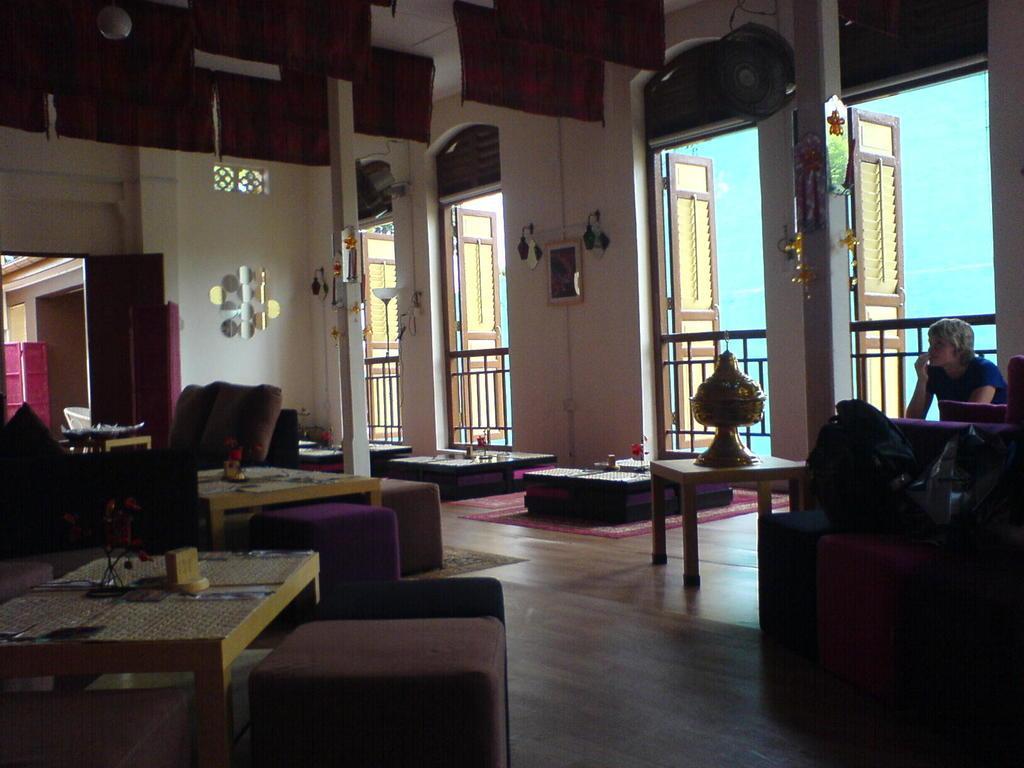How would you summarize this image in a sentence or two? This is the picture of the inside of the house. She is sitting in her room. There is a table,sofa and chair. There is a wooden board on a table. we can in the background there is a door,wall and cupboard,lightnings. 